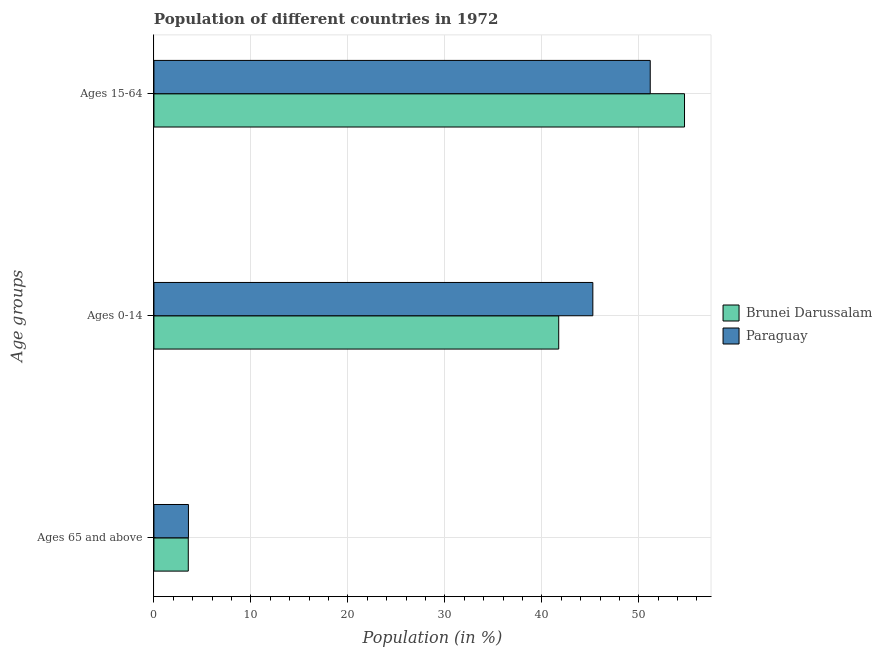How many different coloured bars are there?
Offer a terse response. 2. How many bars are there on the 3rd tick from the top?
Offer a very short reply. 2. How many bars are there on the 1st tick from the bottom?
Your response must be concise. 2. What is the label of the 1st group of bars from the top?
Offer a terse response. Ages 15-64. What is the percentage of population within the age-group of 65 and above in Paraguay?
Make the answer very short. 3.56. Across all countries, what is the maximum percentage of population within the age-group 15-64?
Your response must be concise. 54.71. Across all countries, what is the minimum percentage of population within the age-group 0-14?
Make the answer very short. 41.74. In which country was the percentage of population within the age-group 0-14 maximum?
Your response must be concise. Paraguay. In which country was the percentage of population within the age-group of 65 and above minimum?
Provide a short and direct response. Brunei Darussalam. What is the total percentage of population within the age-group of 65 and above in the graph?
Give a very brief answer. 7.1. What is the difference between the percentage of population within the age-group 0-14 in Paraguay and that in Brunei Darussalam?
Provide a short and direct response. 3.52. What is the difference between the percentage of population within the age-group of 65 and above in Brunei Darussalam and the percentage of population within the age-group 15-64 in Paraguay?
Make the answer very short. -47.64. What is the average percentage of population within the age-group of 65 and above per country?
Your answer should be very brief. 3.55. What is the difference between the percentage of population within the age-group 15-64 and percentage of population within the age-group 0-14 in Paraguay?
Keep it short and to the point. 5.92. In how many countries, is the percentage of population within the age-group 0-14 greater than 46 %?
Offer a very short reply. 0. What is the ratio of the percentage of population within the age-group 15-64 in Paraguay to that in Brunei Darussalam?
Your response must be concise. 0.94. What is the difference between the highest and the second highest percentage of population within the age-group 15-64?
Make the answer very short. 3.54. What is the difference between the highest and the lowest percentage of population within the age-group 0-14?
Keep it short and to the point. 3.52. Is the sum of the percentage of population within the age-group 0-14 in Brunei Darussalam and Paraguay greater than the maximum percentage of population within the age-group of 65 and above across all countries?
Your response must be concise. Yes. What does the 2nd bar from the top in Ages 15-64 represents?
Offer a very short reply. Brunei Darussalam. What does the 2nd bar from the bottom in Ages 0-14 represents?
Make the answer very short. Paraguay. How many countries are there in the graph?
Your answer should be compact. 2. What is the difference between two consecutive major ticks on the X-axis?
Provide a short and direct response. 10. Are the values on the major ticks of X-axis written in scientific E-notation?
Provide a succinct answer. No. Where does the legend appear in the graph?
Offer a very short reply. Center right. How are the legend labels stacked?
Your answer should be very brief. Vertical. What is the title of the graph?
Ensure brevity in your answer.  Population of different countries in 1972. Does "Upper middle income" appear as one of the legend labels in the graph?
Keep it short and to the point. No. What is the label or title of the X-axis?
Provide a succinct answer. Population (in %). What is the label or title of the Y-axis?
Keep it short and to the point. Age groups. What is the Population (in %) of Brunei Darussalam in Ages 65 and above?
Your response must be concise. 3.54. What is the Population (in %) of Paraguay in Ages 65 and above?
Your answer should be very brief. 3.56. What is the Population (in %) of Brunei Darussalam in Ages 0-14?
Offer a very short reply. 41.74. What is the Population (in %) in Paraguay in Ages 0-14?
Ensure brevity in your answer.  45.26. What is the Population (in %) in Brunei Darussalam in Ages 15-64?
Provide a succinct answer. 54.71. What is the Population (in %) in Paraguay in Ages 15-64?
Your response must be concise. 51.18. Across all Age groups, what is the maximum Population (in %) of Brunei Darussalam?
Provide a short and direct response. 54.71. Across all Age groups, what is the maximum Population (in %) in Paraguay?
Offer a terse response. 51.18. Across all Age groups, what is the minimum Population (in %) in Brunei Darussalam?
Offer a very short reply. 3.54. Across all Age groups, what is the minimum Population (in %) of Paraguay?
Your response must be concise. 3.56. What is the difference between the Population (in %) of Brunei Darussalam in Ages 65 and above and that in Ages 0-14?
Ensure brevity in your answer.  -38.2. What is the difference between the Population (in %) of Paraguay in Ages 65 and above and that in Ages 0-14?
Your response must be concise. -41.7. What is the difference between the Population (in %) in Brunei Darussalam in Ages 65 and above and that in Ages 15-64?
Your answer should be compact. -51.17. What is the difference between the Population (in %) in Paraguay in Ages 65 and above and that in Ages 15-64?
Offer a terse response. -47.62. What is the difference between the Population (in %) of Brunei Darussalam in Ages 0-14 and that in Ages 15-64?
Provide a succinct answer. -12.97. What is the difference between the Population (in %) of Paraguay in Ages 0-14 and that in Ages 15-64?
Keep it short and to the point. -5.92. What is the difference between the Population (in %) in Brunei Darussalam in Ages 65 and above and the Population (in %) in Paraguay in Ages 0-14?
Your answer should be very brief. -41.72. What is the difference between the Population (in %) in Brunei Darussalam in Ages 65 and above and the Population (in %) in Paraguay in Ages 15-64?
Make the answer very short. -47.64. What is the difference between the Population (in %) of Brunei Darussalam in Ages 0-14 and the Population (in %) of Paraguay in Ages 15-64?
Offer a very short reply. -9.44. What is the average Population (in %) in Brunei Darussalam per Age groups?
Keep it short and to the point. 33.33. What is the average Population (in %) in Paraguay per Age groups?
Provide a succinct answer. 33.33. What is the difference between the Population (in %) of Brunei Darussalam and Population (in %) of Paraguay in Ages 65 and above?
Give a very brief answer. -0.02. What is the difference between the Population (in %) of Brunei Darussalam and Population (in %) of Paraguay in Ages 0-14?
Your response must be concise. -3.52. What is the difference between the Population (in %) of Brunei Darussalam and Population (in %) of Paraguay in Ages 15-64?
Provide a short and direct response. 3.54. What is the ratio of the Population (in %) of Brunei Darussalam in Ages 65 and above to that in Ages 0-14?
Offer a terse response. 0.08. What is the ratio of the Population (in %) in Paraguay in Ages 65 and above to that in Ages 0-14?
Provide a short and direct response. 0.08. What is the ratio of the Population (in %) in Brunei Darussalam in Ages 65 and above to that in Ages 15-64?
Your response must be concise. 0.06. What is the ratio of the Population (in %) in Paraguay in Ages 65 and above to that in Ages 15-64?
Offer a very short reply. 0.07. What is the ratio of the Population (in %) in Brunei Darussalam in Ages 0-14 to that in Ages 15-64?
Offer a terse response. 0.76. What is the ratio of the Population (in %) of Paraguay in Ages 0-14 to that in Ages 15-64?
Make the answer very short. 0.88. What is the difference between the highest and the second highest Population (in %) of Brunei Darussalam?
Your answer should be compact. 12.97. What is the difference between the highest and the second highest Population (in %) of Paraguay?
Your answer should be compact. 5.92. What is the difference between the highest and the lowest Population (in %) in Brunei Darussalam?
Your response must be concise. 51.17. What is the difference between the highest and the lowest Population (in %) of Paraguay?
Your answer should be very brief. 47.62. 